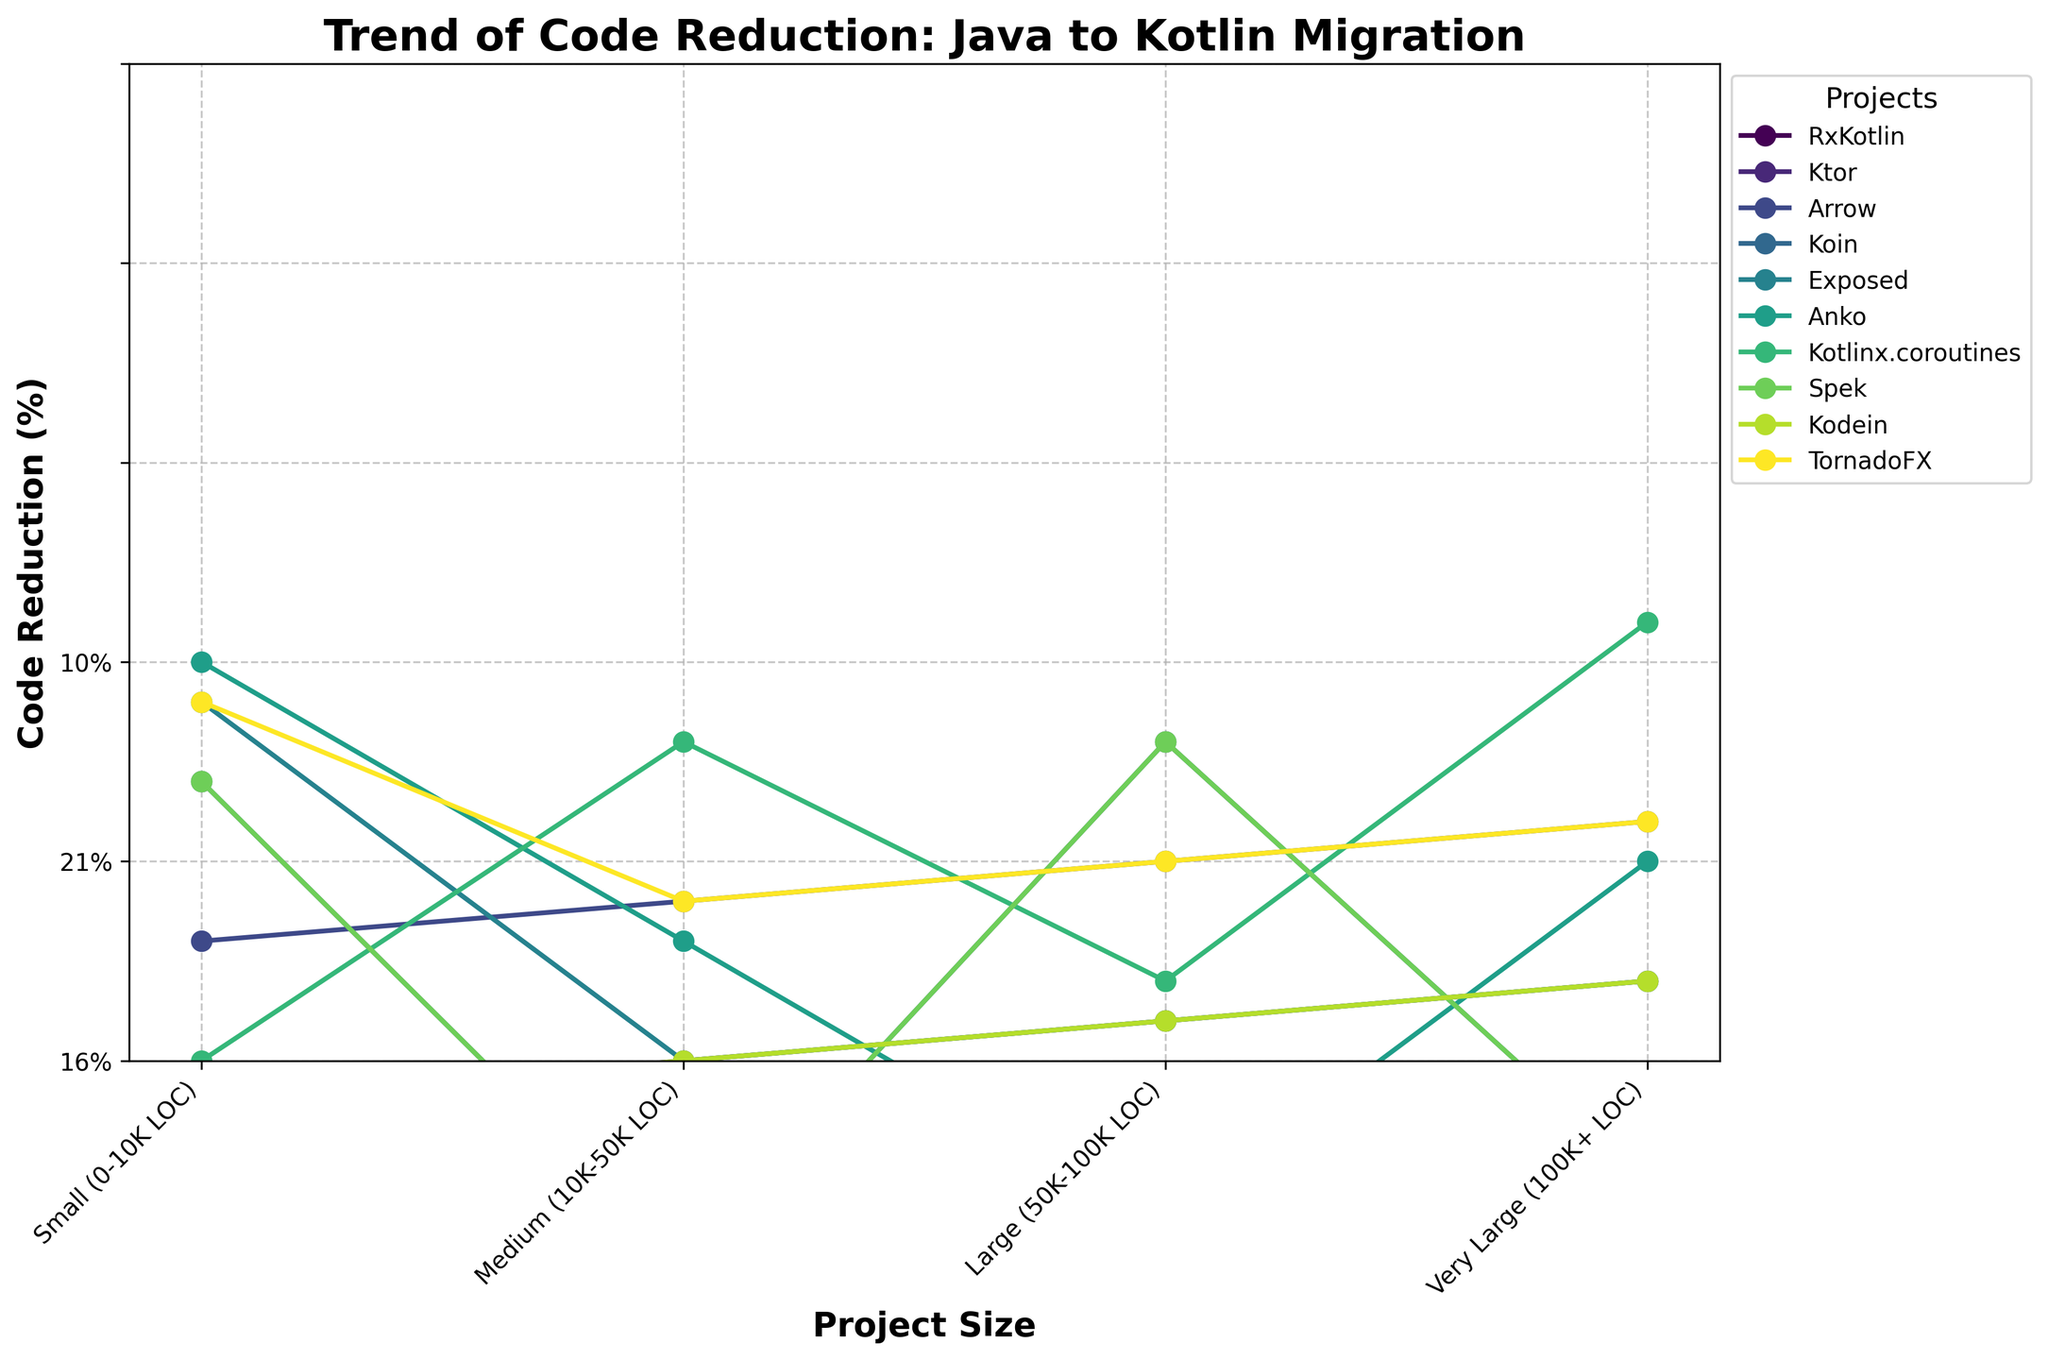What's the average percentage of code reduction for the 'Medium' project size across all projects? To find the average for the 'Medium' project size, sum the percentages for all projects in this category and then divide by the number of projects. The percentages are 18%, 16%, 17%, 15%, 16%, 14%, 19%, 15%, 16%, and 17%. Summing these gives 163%. Dividing 163% by 10 gives 16.3%.
Answer: 16.3% Which project shows the highest code reduction for 'Very Large' projects? By looking at the plot, we can observe the markers at the 'Very Large' category. The highest percentage in the 'Very Large' category is 26%, which corresponds to 'Kotlinx.coroutines'.
Answer: 'Kotlinx.coroutines' What is the difference in percentage reduction for 'Small' and 'Very Large' project sizes for the 'RxKotlin' project? The percentage reduction for 'RxKotlin' in the 'Small' category is 15%, and it is 25% for the 'Very Large' category. The difference is 25% - 15% = 10%.
Answer: 10% For which project is the increase in code reduction from 'Small' to 'Medium' project size the smallest? To determine this, check the figure for the smallest rise between 'Small' and 'Medium' project sizes across all projects. 'Anko' shows the smallest increase, from 10% to 14%, which is a rise of 4%.
Answer: 'Anko' Which two projects have identical trends without any deviation across different project sizes? Identical trends occur when all percentage values match for each size category. In this case, 'Ktor' and 'Exposed' both show identical percentages in all categories: 12%, 16%, 20%, and 23%.
Answer: 'Ktor' and 'Exposed' How does the code reduction for 'Large' projects compare between 'Arrow' and 'TornadoFX'? Observing the 'Large' project size category, 'Arrow' shows a 21% reduction, while 'TornadoFX' shows the same 21% reduction. Thus, they are equal.
Answer: Equal What is the overall trend in code reduction as the project size increases for 'Koin'? Look at 'Koin's percentages across increasing project sizes: 11%, 15%, 19%, 22%. The trend shows a progressive increase in code reduction as the project size increases.
Answer: Increasing Which project has the lowest code reduction percentage for 'Medium' project size? Identify the smallest value in the 'Medium' category. 'Anko' has the lowest percentage reduction of 14% for this category.
Answer: 'Anko' Calculate the total sum of code reduction percentages for 'Spek' across all project sizes. Sum the values for the 'Spek' project: 11% + 15% + 19% + 22%. Summing these gives 67%.
Answer: 67% What is the difference in code reduction percentage for the 'Medium' project size between 'RxKotlin' and 'Ktor'? For 'RxKotlin', the reduction is 18%, and for 'Ktor' it is 16%. The difference is 18% - 16% = 2%.
Answer: 2% 